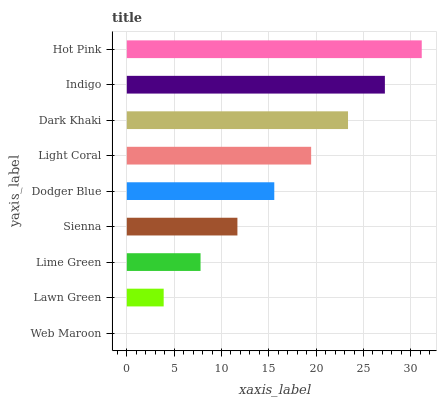Is Web Maroon the minimum?
Answer yes or no. Yes. Is Hot Pink the maximum?
Answer yes or no. Yes. Is Lawn Green the minimum?
Answer yes or no. No. Is Lawn Green the maximum?
Answer yes or no. No. Is Lawn Green greater than Web Maroon?
Answer yes or no. Yes. Is Web Maroon less than Lawn Green?
Answer yes or no. Yes. Is Web Maroon greater than Lawn Green?
Answer yes or no. No. Is Lawn Green less than Web Maroon?
Answer yes or no. No. Is Dodger Blue the high median?
Answer yes or no. Yes. Is Dodger Blue the low median?
Answer yes or no. Yes. Is Lime Green the high median?
Answer yes or no. No. Is Dark Khaki the low median?
Answer yes or no. No. 